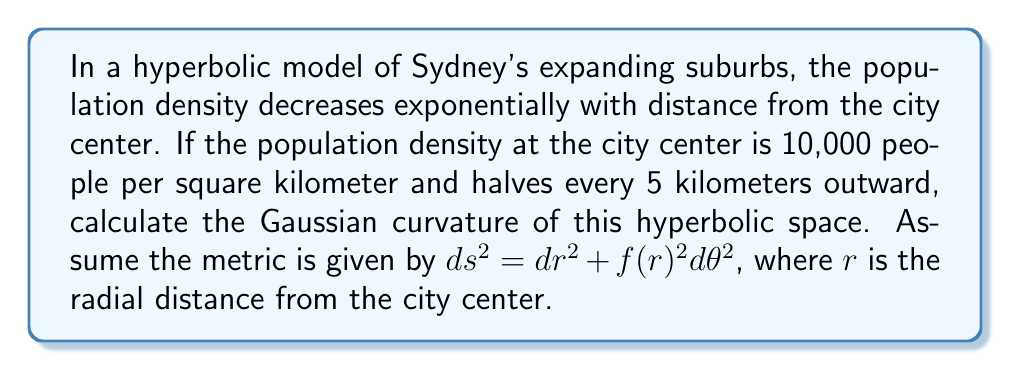Solve this math problem. 1) In a hyperbolic space with radial symmetry, the metric can be written as:
   $$ds^2 = dr^2 + f(r)^2 d\theta^2$$

2) The population density function can be expressed as:
   $$\rho(r) = 10000 \cdot 2^{-r/5}$$

3) In a hyperbolic space with this density distribution, $f(r)$ satisfies:
   $$f''(r) = -K \cdot f(r)$$
   where $K$ is the Gaussian curvature.

4) The solution to this differential equation that matches our density function is:
   $$f(r) = \frac{5}{\sqrt{K}} \sinh(\sqrt{K}r)$$

5) Comparing this with our density function:
   $$\frac{5}{\sqrt{K}} \sinh(\sqrt{K}r) = 10000 \cdot 2^{-r/5}$$

6) Taking the logarithm of both sides:
   $$\ln(5) - \frac{1}{2}\ln(K) + \ln(\sinh(\sqrt{K}r)) = \ln(10000) - \frac{r\ln(2)}{5}$$

7) Differentiating both sides with respect to $r$:
   $$\sqrt{K} \coth(\sqrt{K}r) = -\frac{\ln(2)}{5}$$

8) This equation should hold for all $r$. Let's consider $r \to 0$:
   $$\sqrt{K} = -\frac{\ln(2)}{5}$$

9) Squaring both sides:
   $$K = \frac{(\ln(2))^2}{25} \approx 0.0019$$
Answer: $K = \frac{(\ln(2))^2}{25} \approx 0.0019 \text{ km}^{-2}$ 